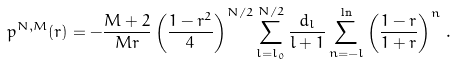Convert formula to latex. <formula><loc_0><loc_0><loc_500><loc_500>p ^ { N , M } ( r ) = - \frac { M + 2 } { M r } \left ( \frac { 1 - r ^ { 2 } } { 4 } \right ) ^ { N / 2 } \sum _ { l = l _ { 0 } } ^ { N / 2 } \frac { d _ { l } } { l + 1 } \sum _ { n = - l } ^ { \ln } \left ( \frac { 1 - r } { 1 + r } \right ) ^ { n } \, .</formula> 